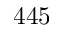<formula> <loc_0><loc_0><loc_500><loc_500>4 4 5</formula> 